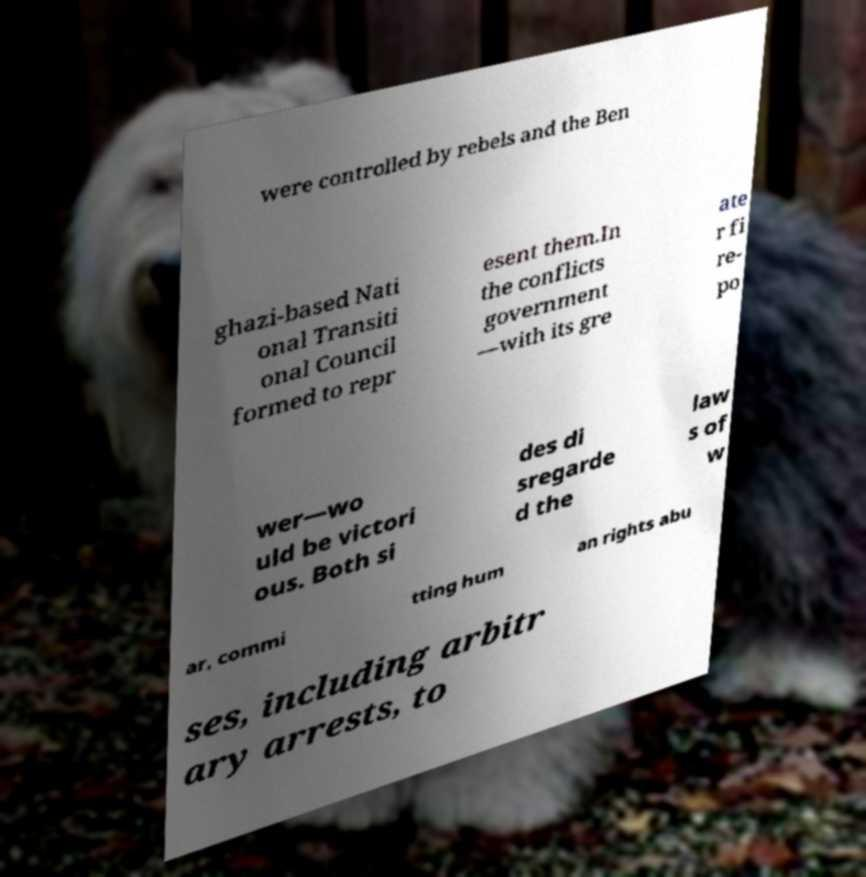What messages or text are displayed in this image? I need them in a readable, typed format. were controlled by rebels and the Ben ghazi-based Nati onal Transiti onal Council formed to repr esent them.In the conflicts government —with its gre ate r fi re- po wer—wo uld be victori ous. Both si des di sregarde d the law s of w ar, commi tting hum an rights abu ses, including arbitr ary arrests, to 